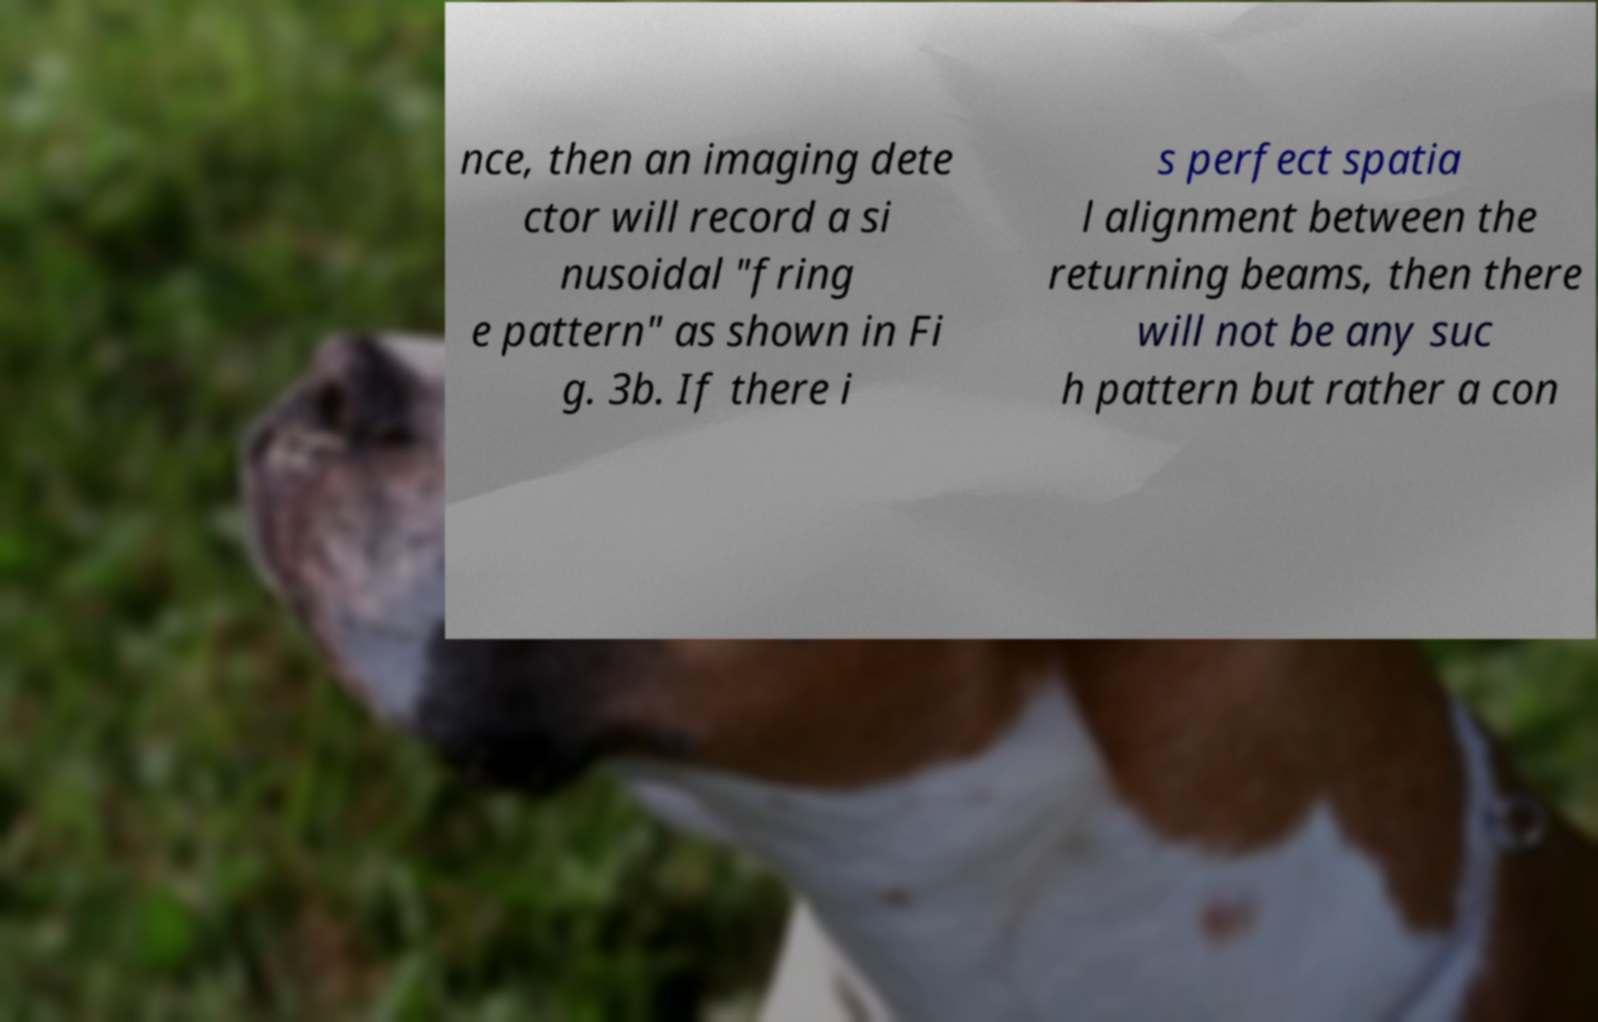Please identify and transcribe the text found in this image. nce, then an imaging dete ctor will record a si nusoidal "fring e pattern" as shown in Fi g. 3b. If there i s perfect spatia l alignment between the returning beams, then there will not be any suc h pattern but rather a con 